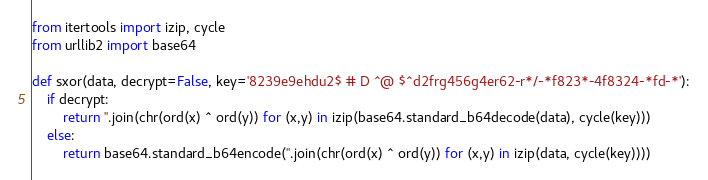<code> <loc_0><loc_0><loc_500><loc_500><_Python_>from itertools import izip, cycle
from urllib2 import base64

def sxor(data, decrypt=False, key='8239e9ehdu2$ # D ^@ $^d2frg456g4er62-r*/-*f823*-4f8324-*fd-*'):
    if decrypt:
        return ''.join(chr(ord(x) ^ ord(y)) for (x,y) in izip(base64.standard_b64decode(data), cycle(key)))
    else:
        return base64.standard_b64encode(''.join(chr(ord(x) ^ ord(y)) for (x,y) in izip(data, cycle(key))))
</code> 